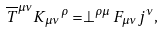Convert formula to latex. <formula><loc_0><loc_0><loc_500><loc_500>\overline { T } ^ { \mu \nu } K { _ { \mu \nu } } ^ { \rho } = \perp ^ { \rho \mu } F _ { \mu \nu } j ^ { \nu } ,</formula> 